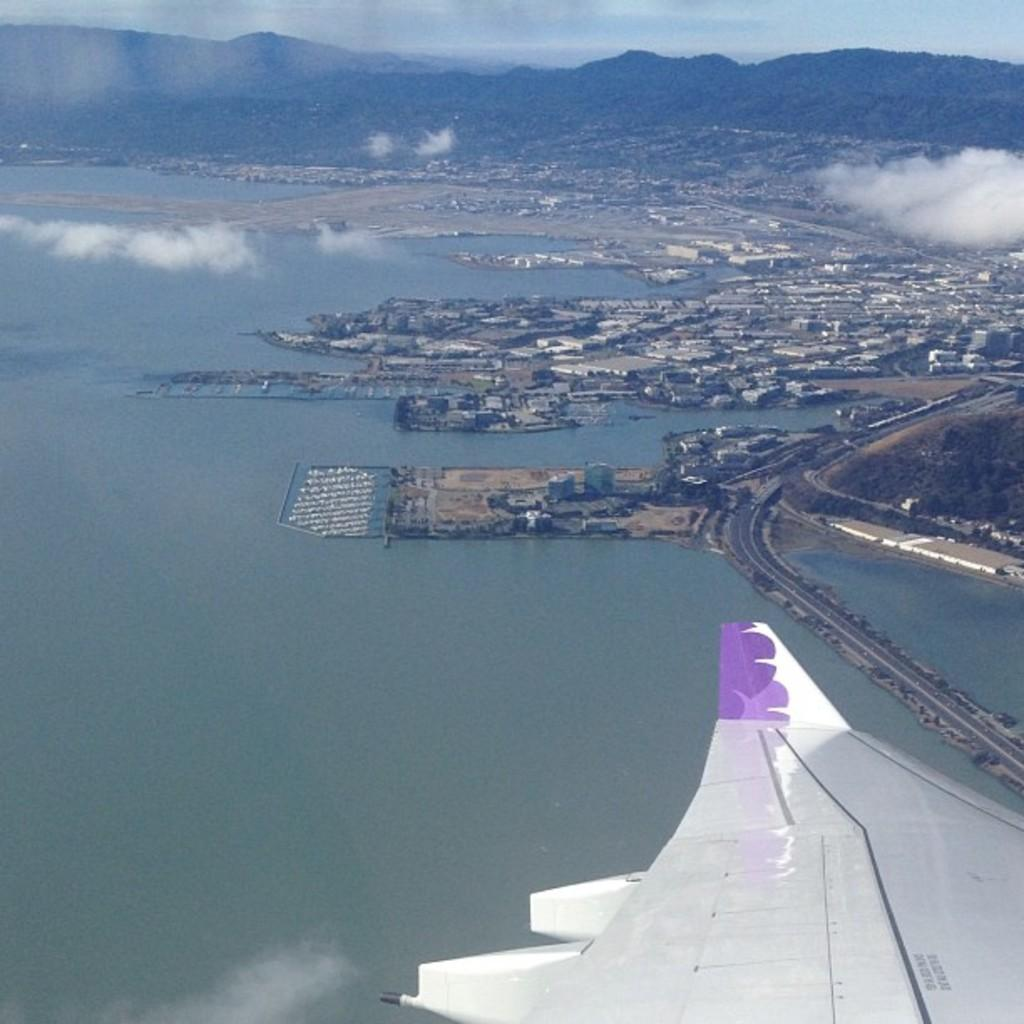What is the main subject of the image? The main subject of the image is an aircraft's wing. What else can be seen in the image besides the aircraft's wing? There are houses, trees, a sea, and mountains in the image. How many experts are present in the image? There is no mention of experts in the image; it features an aircraft's wing, houses, trees, a sea, and mountains. What type of education is being provided in the image? There is no indication of any educational activity in the image. 